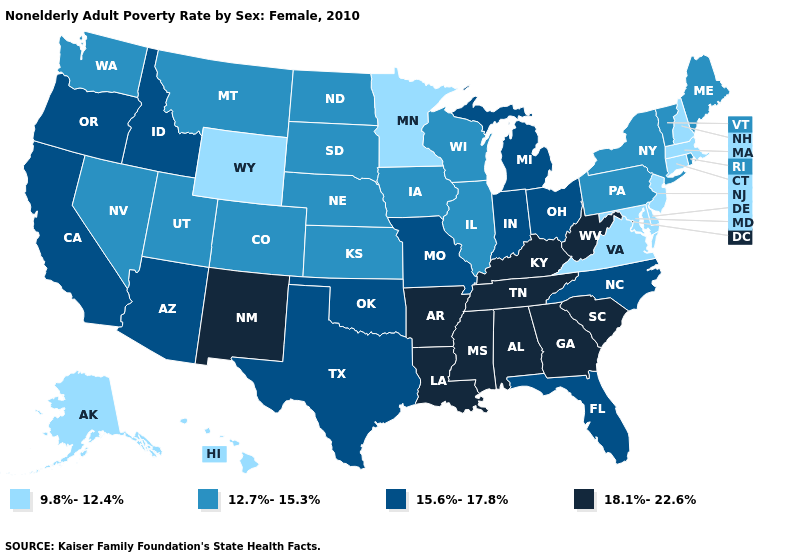Name the states that have a value in the range 12.7%-15.3%?
Concise answer only. Colorado, Illinois, Iowa, Kansas, Maine, Montana, Nebraska, Nevada, New York, North Dakota, Pennsylvania, Rhode Island, South Dakota, Utah, Vermont, Washington, Wisconsin. Does New Mexico have the same value as Massachusetts?
Quick response, please. No. Does the map have missing data?
Be succinct. No. What is the highest value in the USA?
Quick response, please. 18.1%-22.6%. Name the states that have a value in the range 18.1%-22.6%?
Answer briefly. Alabama, Arkansas, Georgia, Kentucky, Louisiana, Mississippi, New Mexico, South Carolina, Tennessee, West Virginia. Among the states that border Massachusetts , which have the lowest value?
Keep it brief. Connecticut, New Hampshire. Among the states that border California , does Nevada have the lowest value?
Quick response, please. Yes. Among the states that border Illinois , which have the highest value?
Concise answer only. Kentucky. What is the value of Idaho?
Quick response, please. 15.6%-17.8%. Name the states that have a value in the range 18.1%-22.6%?
Concise answer only. Alabama, Arkansas, Georgia, Kentucky, Louisiana, Mississippi, New Mexico, South Carolina, Tennessee, West Virginia. Name the states that have a value in the range 18.1%-22.6%?
Give a very brief answer. Alabama, Arkansas, Georgia, Kentucky, Louisiana, Mississippi, New Mexico, South Carolina, Tennessee, West Virginia. Name the states that have a value in the range 18.1%-22.6%?
Short answer required. Alabama, Arkansas, Georgia, Kentucky, Louisiana, Mississippi, New Mexico, South Carolina, Tennessee, West Virginia. Which states have the highest value in the USA?
Be succinct. Alabama, Arkansas, Georgia, Kentucky, Louisiana, Mississippi, New Mexico, South Carolina, Tennessee, West Virginia. Name the states that have a value in the range 9.8%-12.4%?
Write a very short answer. Alaska, Connecticut, Delaware, Hawaii, Maryland, Massachusetts, Minnesota, New Hampshire, New Jersey, Virginia, Wyoming. Does Nebraska have a higher value than New Jersey?
Answer briefly. Yes. 